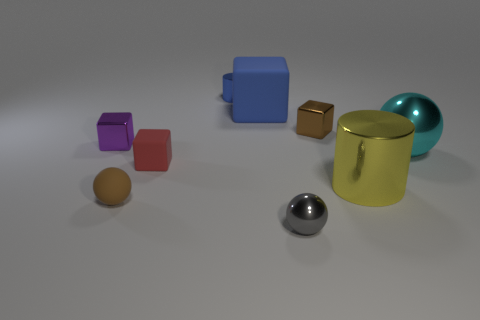There is a object that is the same color as the big rubber cube; what size is it?
Offer a terse response. Small. What is the material of the cylinder that is in front of the shiny cube on the right side of the brown rubber object?
Keep it short and to the point. Metal. How big is the rubber object behind the metallic ball that is behind the small red matte thing to the left of the blue matte block?
Keep it short and to the point. Large. How many big yellow cylinders have the same material as the tiny red cube?
Your response must be concise. 0. There is a rubber thing that is to the right of the matte cube that is left of the large blue matte object; what color is it?
Make the answer very short. Blue. How many objects are small brown matte spheres or spheres to the right of the small cylinder?
Provide a short and direct response. 3. Are there any shiny blocks of the same color as the matte ball?
Give a very brief answer. Yes. What number of purple things are either small metallic cylinders or small cubes?
Keep it short and to the point. 1. How many other objects are the same size as the gray sphere?
Your answer should be very brief. 5. What number of big objects are either yellow cylinders or cyan metallic balls?
Keep it short and to the point. 2. 